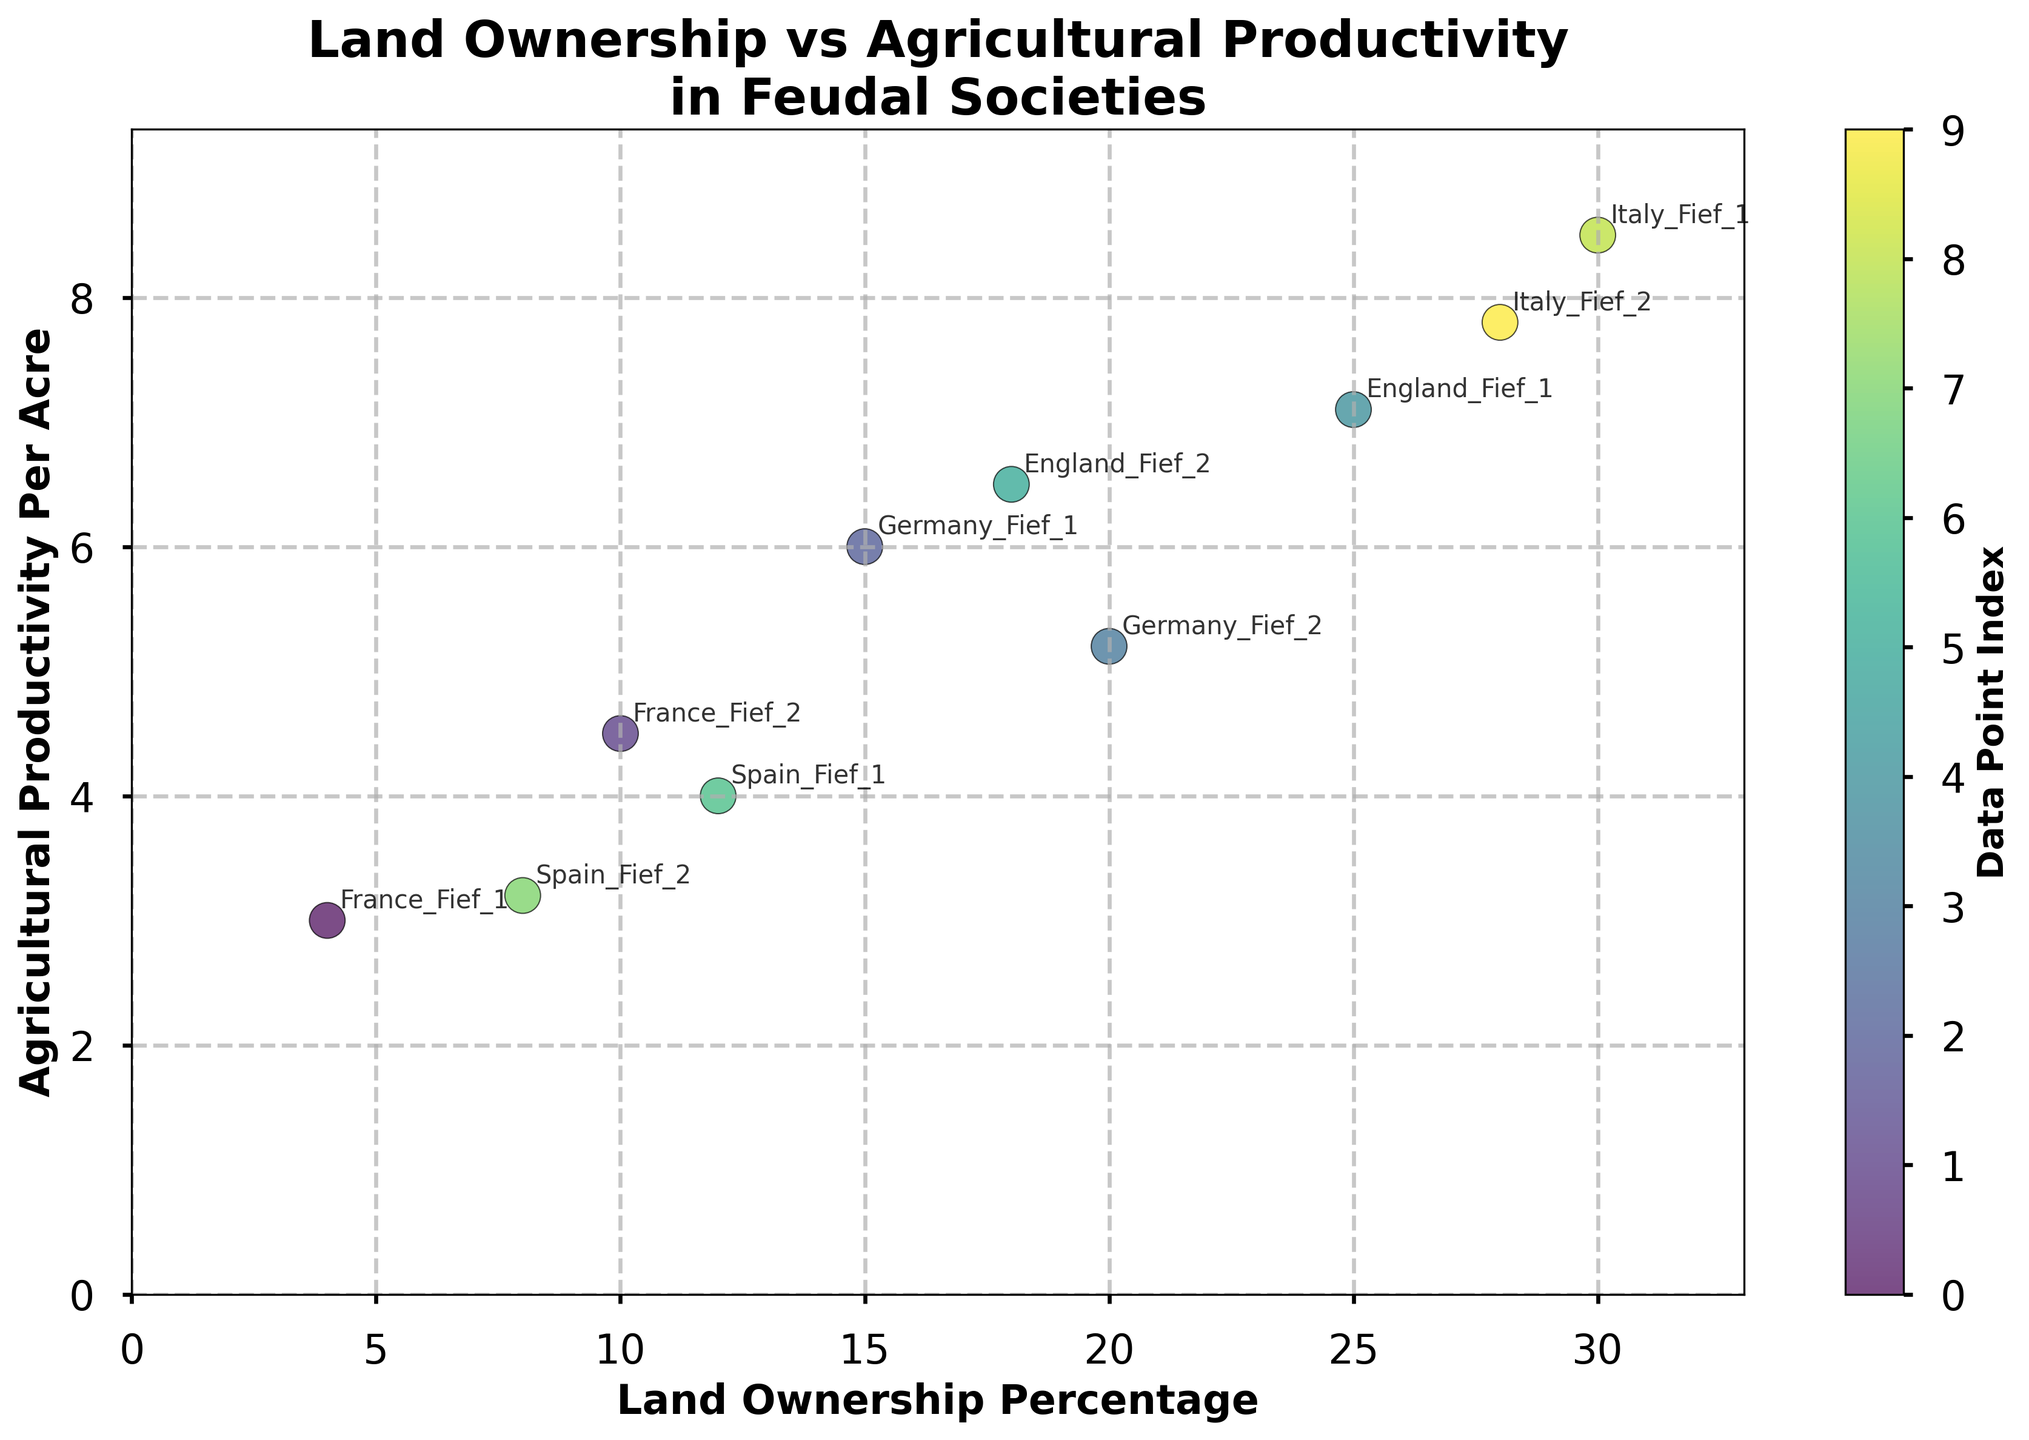How many data points are represented in the scatter plot? Count the number of data points used in generating the scatter plot. Each point represents a combination of Land Ownership Percentage and Agricultural Productivity Per Acre. There are 10 points listed in the raw data.
Answer: 10 Which country shows the highest agricultural productivity per acre? Check the label annotations in the scatter plot for the highest value on the y-axis, representing Agricultural Productivity Per Acre. Italy Fief 1 is at 8.5.
Answer: Italy What is the land ownership percentage where England Fief 1 has the highest agricultural productivity? Locate the data point for "England Fief 1" in the scatter plot. According to the data, this corresponds to the percentage of 25%.
Answer: 25% Which country has the lowest combination of land ownership percentage and agricultural productivity? Evaluate the data points and identify the one with both low values on x (Land Ownership Percentage) and y (Agricultural Productivity Per Acre). France Fief 1 is at 4% and 3.0, respectively.
Answer: France How does the agricultural productivity per acre for Germany Fief 1 compare to that of Spain Fief 2? Look at the y-axis values for both "Germany Fief 1" and "Spain Fief 2". Germany Fief 1 has 6.0, and Spain Fief 2 has 3.2. 6.0 is greater than 3.2.
Answer: Germany Fief 1 is higher What is the average agricultural productivity for the Italian fiefdoms in the graph? Identify the productivity values for "Italy Fief 1" (8.5) and "Italy Fief 2" (7.8). Compute the average: (8.5 + 7.8) / 2 = 8.15.
Answer: 8.15 What can be inferred about land ownership percentage and productivity for the English fiefdoms? Locate the points for "England Fief 1" and "England Fief 2". England Fief 1 has 25% ownership and 7.1 productivity, while England Fief 2 has 18% ownership and 6.5 productivity. Generally, higher ownership corresponds to higher productivity in this case.
Answer: Higher ownership leads to higher productivity Which country shows the smallest difference in agricultural productivity between its two fiefdoms? Calculate the difference in agricultural productivity for each pair: France (4.5 - 3.0 = 1.5), Germany (6.0 - 5.2 = 0.8), England (7.1 - 6.5 = 0.6), Spain (4.0 - 3.2 = 0.8), and Italy (8.5 - 7.8 = 0.7). The smallest difference is between "England Fief 1" and "England Fief 2" at 0.6.
Answer: England What pattern is observed between land ownership percentage and agricultural productivity across all the data points? Examine the scatter plot trend. Generally, data points with higher land ownership percentages seem to have higher agricultural productivity. This indicates a positive correlation between land ownership and productivity.
Answer: Positive correlation 